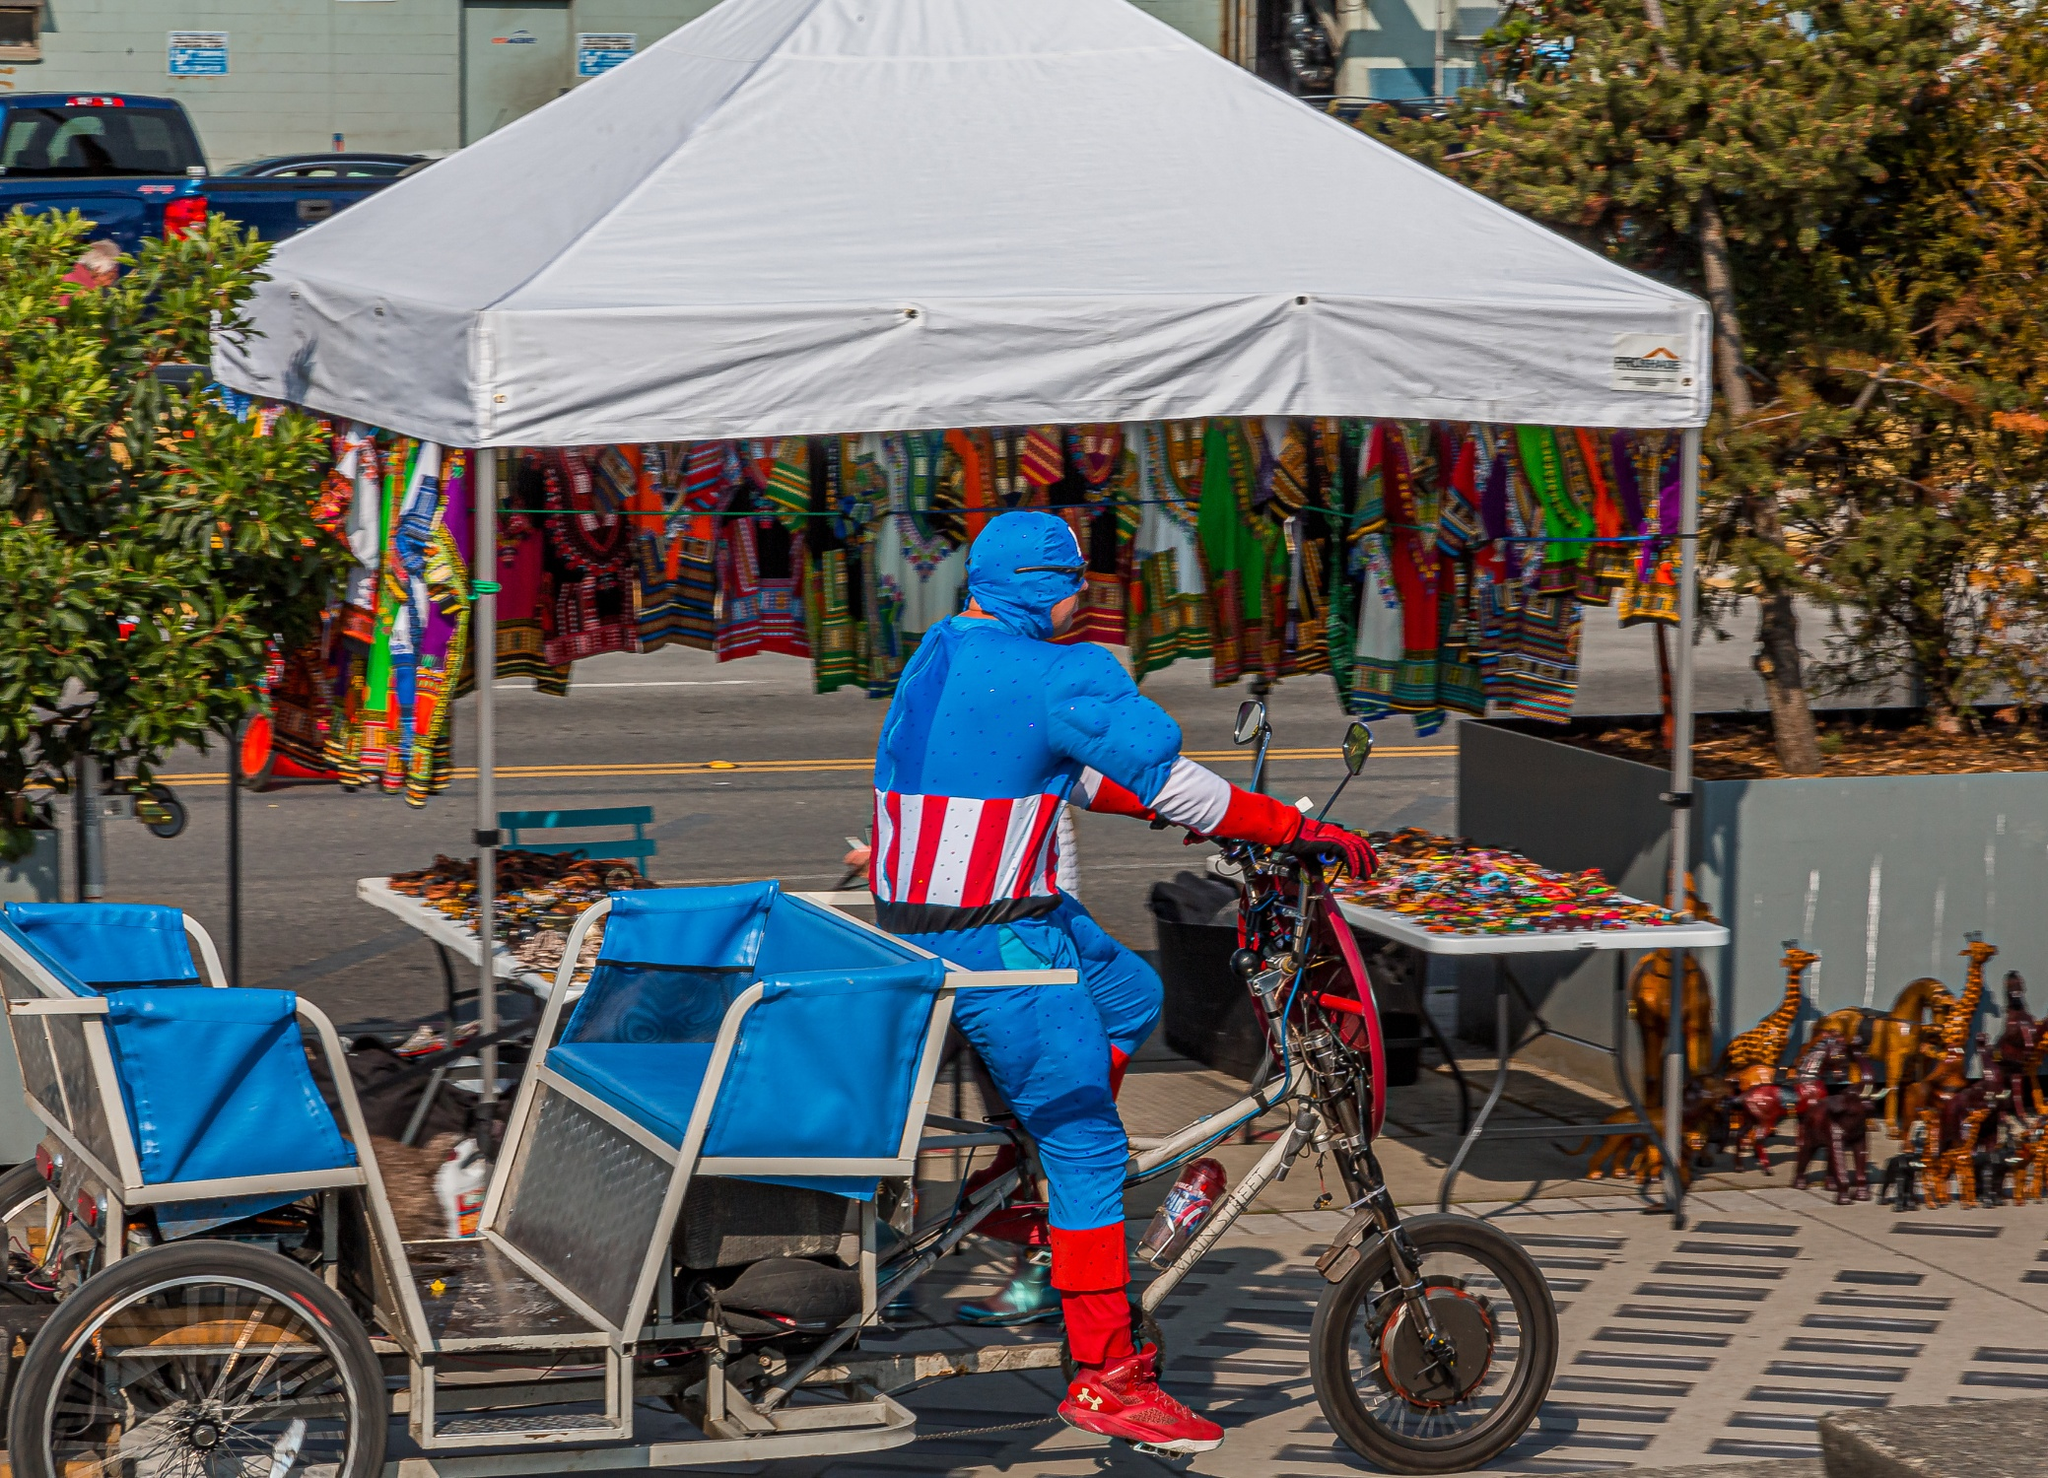What could be the purpose of the cyclist wearing a Captain America costume in this setting? The individual wearing the Captain America costume may be participating in a themed event, like a parade, a promotional activity, or a charity ride. The costume brings attention and fun to the event, suggesting a celebration or public gathering where entertainment and possibly fundraising are involved. This kind of attire in a busy market setting likely aims to catch the eye of passersby, adding a splash of color and whimsy to their day. 